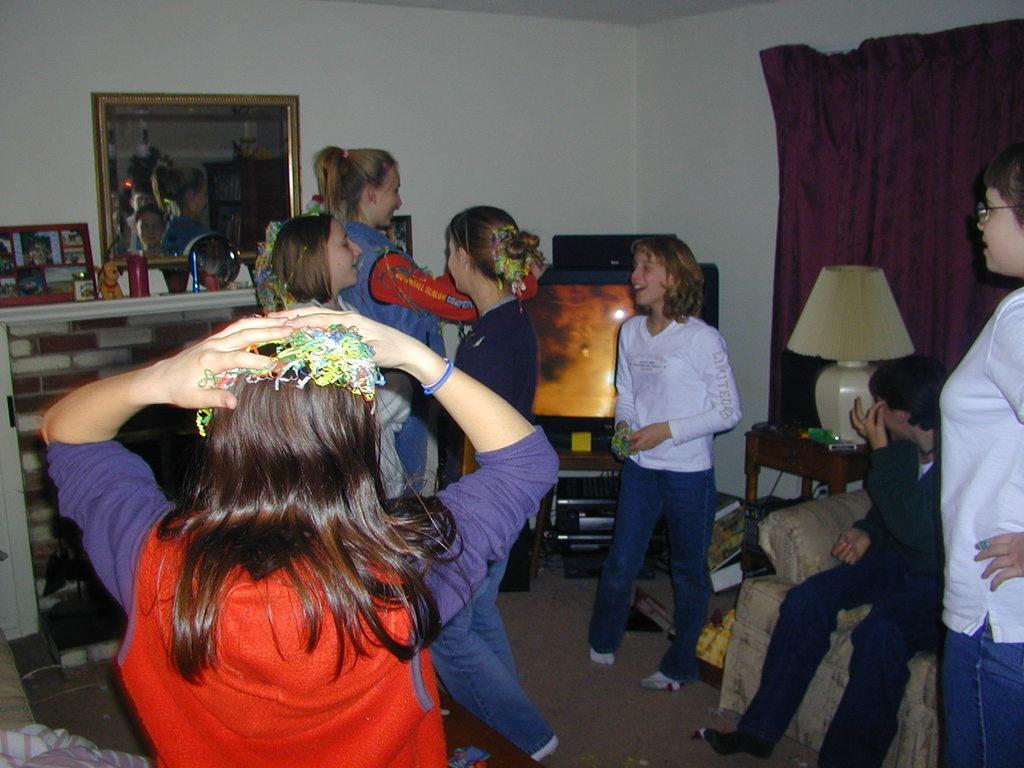How would you summarize this image in a sentence or two? In this picture we can see some people where some are standing and some are sitting and besides to them there is table, television, lamp and in background we can see curtain, wall, frame. 